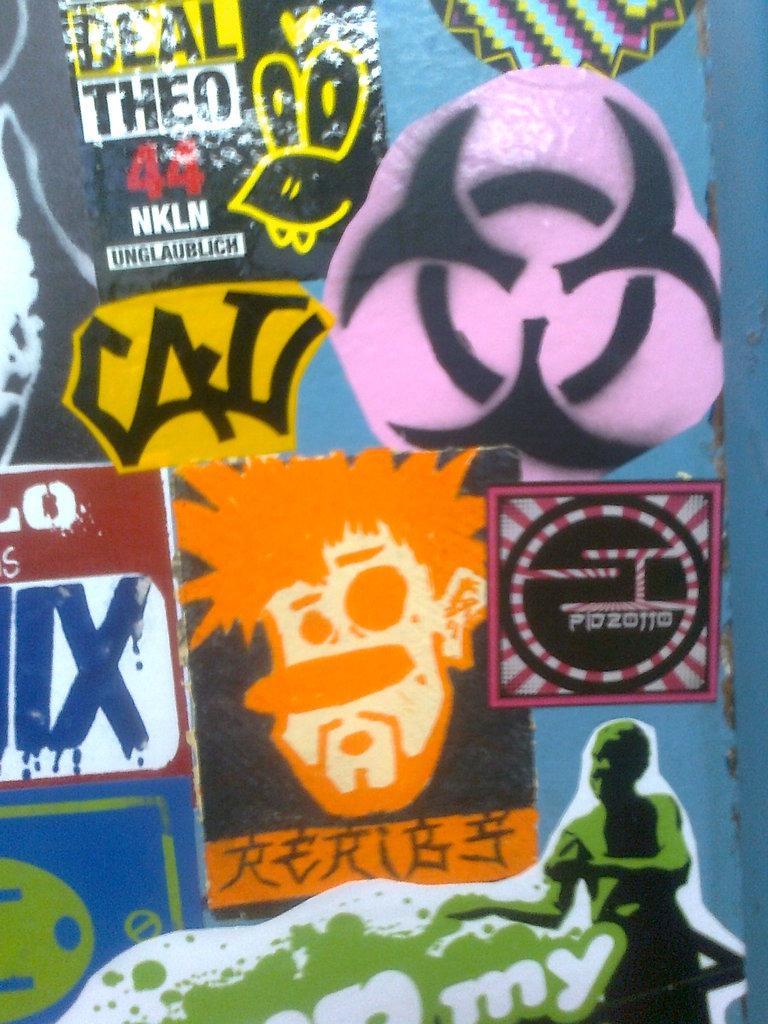Describe this image in one or two sentences. In the image in the center we can see one poster. On the poster,we can see one human face. And we can see something written on the poster. 